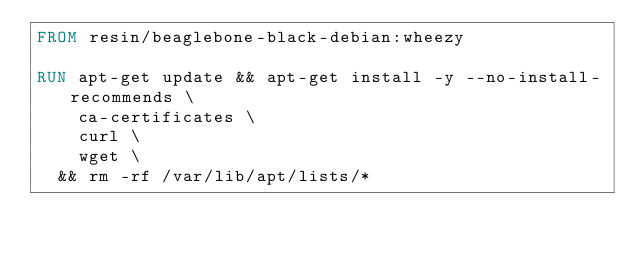Convert code to text. <code><loc_0><loc_0><loc_500><loc_500><_Dockerfile_>FROM resin/beaglebone-black-debian:wheezy

RUN apt-get update && apt-get install -y --no-install-recommends \
		ca-certificates \
		curl \
		wget \
	&& rm -rf /var/lib/apt/lists/*
</code> 